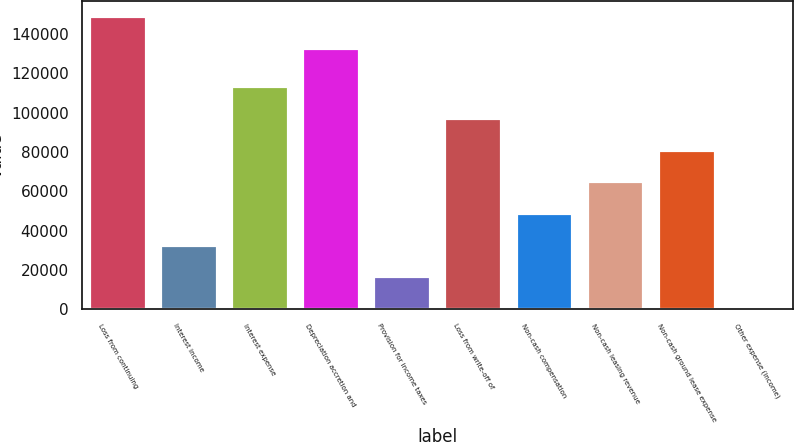Convert chart to OTSL. <chart><loc_0><loc_0><loc_500><loc_500><bar_chart><fcel>Loss from continuing<fcel>Interest income<fcel>Interest expense<fcel>Depreciation accretion and<fcel>Provision for income taxes<fcel>Loss from write-off of<fcel>Non-cash compensation<fcel>Non-cash leasing revenue<fcel>Non-cash ground lease expense<fcel>Other expense (income)<nl><fcel>149200<fcel>32916.4<fcel>113477<fcel>133088<fcel>16804.2<fcel>97365.2<fcel>49028.6<fcel>65140.8<fcel>81253<fcel>692<nl></chart> 